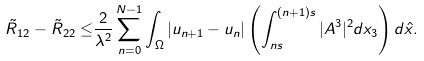Convert formula to latex. <formula><loc_0><loc_0><loc_500><loc_500>\tilde { R } _ { 1 2 } - \tilde { R } _ { 2 2 } \leq & \frac { 2 } { \lambda ^ { 2 } } \sum ^ { N - 1 } _ { n = 0 } \int _ { \Omega } | u _ { n + 1 } - u _ { n } | \left ( \int _ { n s } ^ { ( n + 1 ) s } | A ^ { 3 } | ^ { 2 } d x _ { 3 } \right ) d \hat { x } .</formula> 